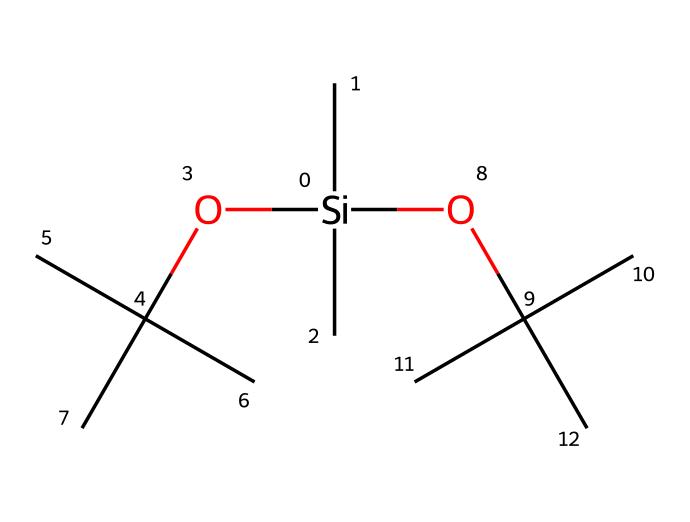What is the central atom in this chemical structure? The central atom is silicon, as indicated by the presence of the silicon atom "Si" at the center of the given SMILES representation.
Answer: silicon How many carbon atoms are present in this compound? By analyzing the structure, we can count the carbon atoms represented in the molecular formula, which totals to 12 carbon atoms around the silicon atom and in the branches.
Answer: 12 What functional groups are present in this structure? The structure contains ether functional groups, indicated by the presence of "O" atoms bonded to carbon chains. Such groups are typical in silicone lubricants.
Answer: ethers How many oxygen atoms are in the molecular composition? Counting the "O" symbols in the SMILES representation shows there are 3 oxygen atoms bonded to carbon groups.
Answer: 3 What type of chemical bond is predominantly found in this compound? The structure largely consists of single covalent bonds, indicated by the absence of double or triple bond symbols between the atoms in the SMILES representation.
Answer: single covalent bonds Is this compound likely to be polar or nonpolar? Considering the structure's lack of significant electronegative atoms apart from the oxygen and the central silicon surrounded by hydrophobic carbon chains, it is likely nonpolar.
Answer: nonpolar 